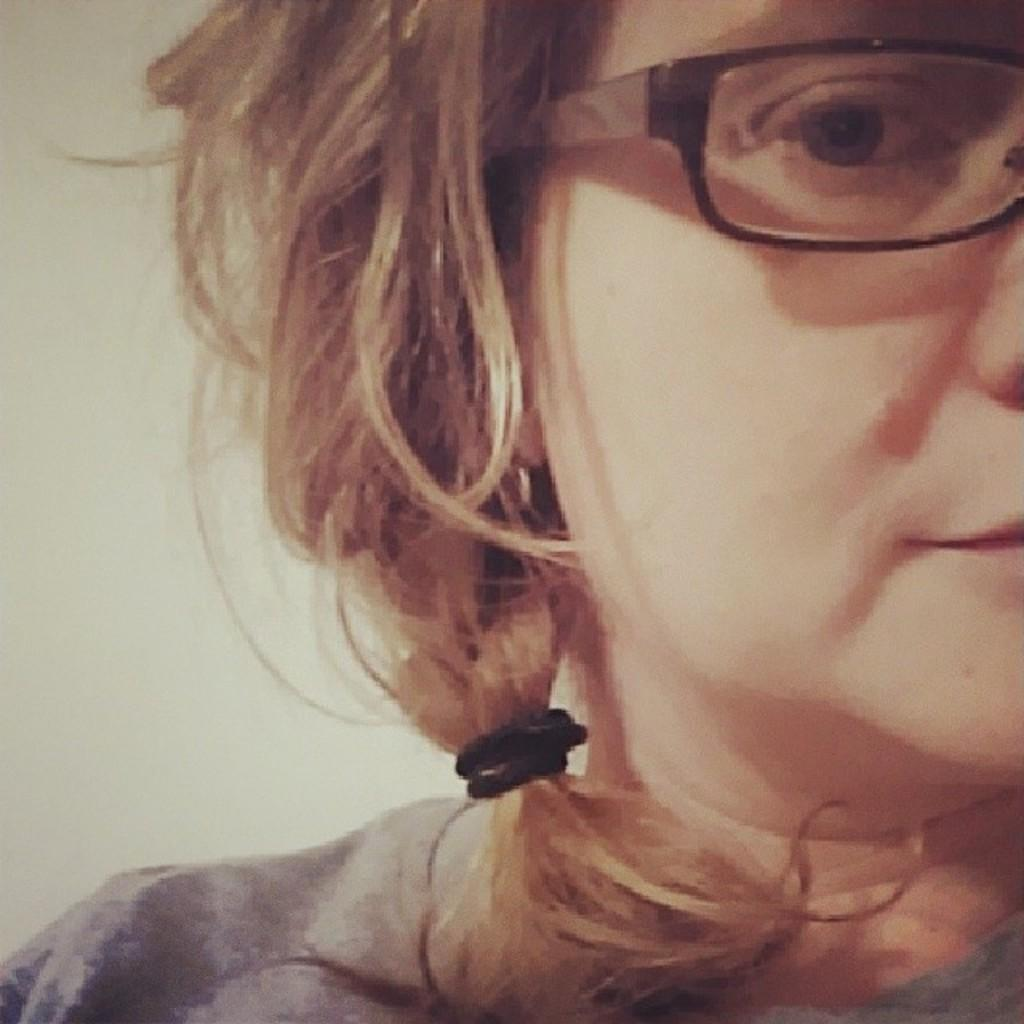Where was the image taken? The image was taken indoors. What can be seen in the background of the image? There is a wall in the background of the image. Who is present in the image? There is a girl on the right side of the image. What is the girl wearing on her upper body? The girl is wearing a T-shirt. What accessory is the girl wearing on her face? The girl is wearing spectacles. What type of stem can be seen growing from the mailbox in the image? There is no mailbox or stem present in the image; it is taken indoors and features a girl wearing spectacles. 